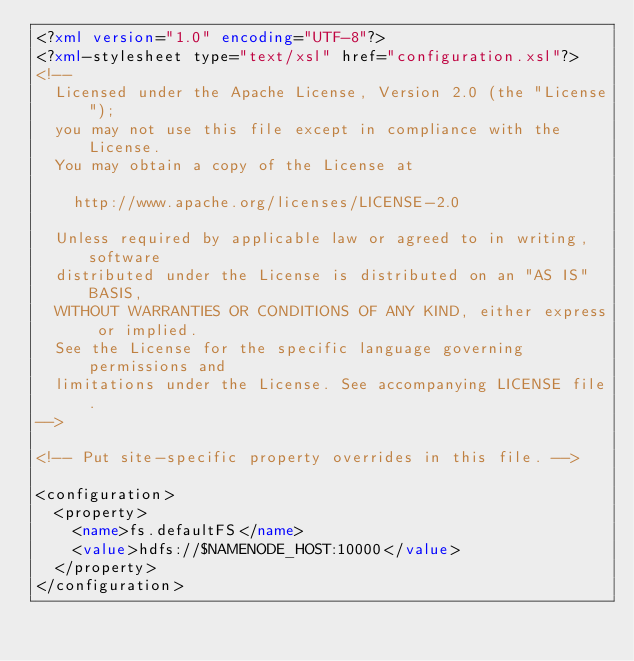<code> <loc_0><loc_0><loc_500><loc_500><_XML_><?xml version="1.0" encoding="UTF-8"?>
<?xml-stylesheet type="text/xsl" href="configuration.xsl"?>
<!--
  Licensed under the Apache License, Version 2.0 (the "License");
  you may not use this file except in compliance with the License.
  You may obtain a copy of the License at

    http://www.apache.org/licenses/LICENSE-2.0

  Unless required by applicable law or agreed to in writing, software
  distributed under the License is distributed on an "AS IS" BASIS,
  WITHOUT WARRANTIES OR CONDITIONS OF ANY KIND, either express or implied.
  See the License for the specific language governing permissions and
  limitations under the License. See accompanying LICENSE file.
-->

<!-- Put site-specific property overrides in this file. -->

<configuration>
  <property>
    <name>fs.defaultFS</name> 
    <value>hdfs://$NAMENODE_HOST:10000</value>
  </property>
</configuration>
</code> 